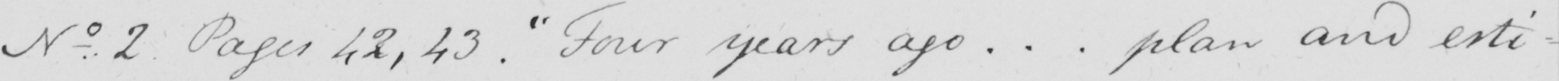What is written in this line of handwriting? No . 2 Pages 42 , 43 .  " Four years ago .. . plan and esti- 